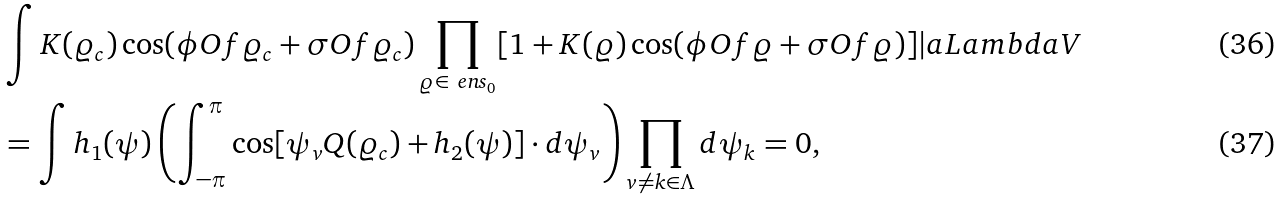<formula> <loc_0><loc_0><loc_500><loc_500>& \int K ( \varrho _ { c } ) \cos ( \phi O f { \varrho _ { c } } + \sigma O f { \varrho _ { c } } ) \prod _ { \varrho \in \ e n s _ { 0 } } [ 1 + K ( \varrho ) \cos ( \phi O f { \varrho } + \sigma O f { \varrho } ) ] | a L a m b d a V \\ & = \int h _ { 1 } ( \psi ) \left ( \int _ { - \pi } ^ { \pi } \cos [ \psi _ { v } Q ( \varrho _ { c } ) + h _ { 2 } ( \psi ) ] \cdot d \psi _ { v } \right ) \prod _ { v \neq k \in \Lambda } d \psi _ { k } = 0 ,</formula> 